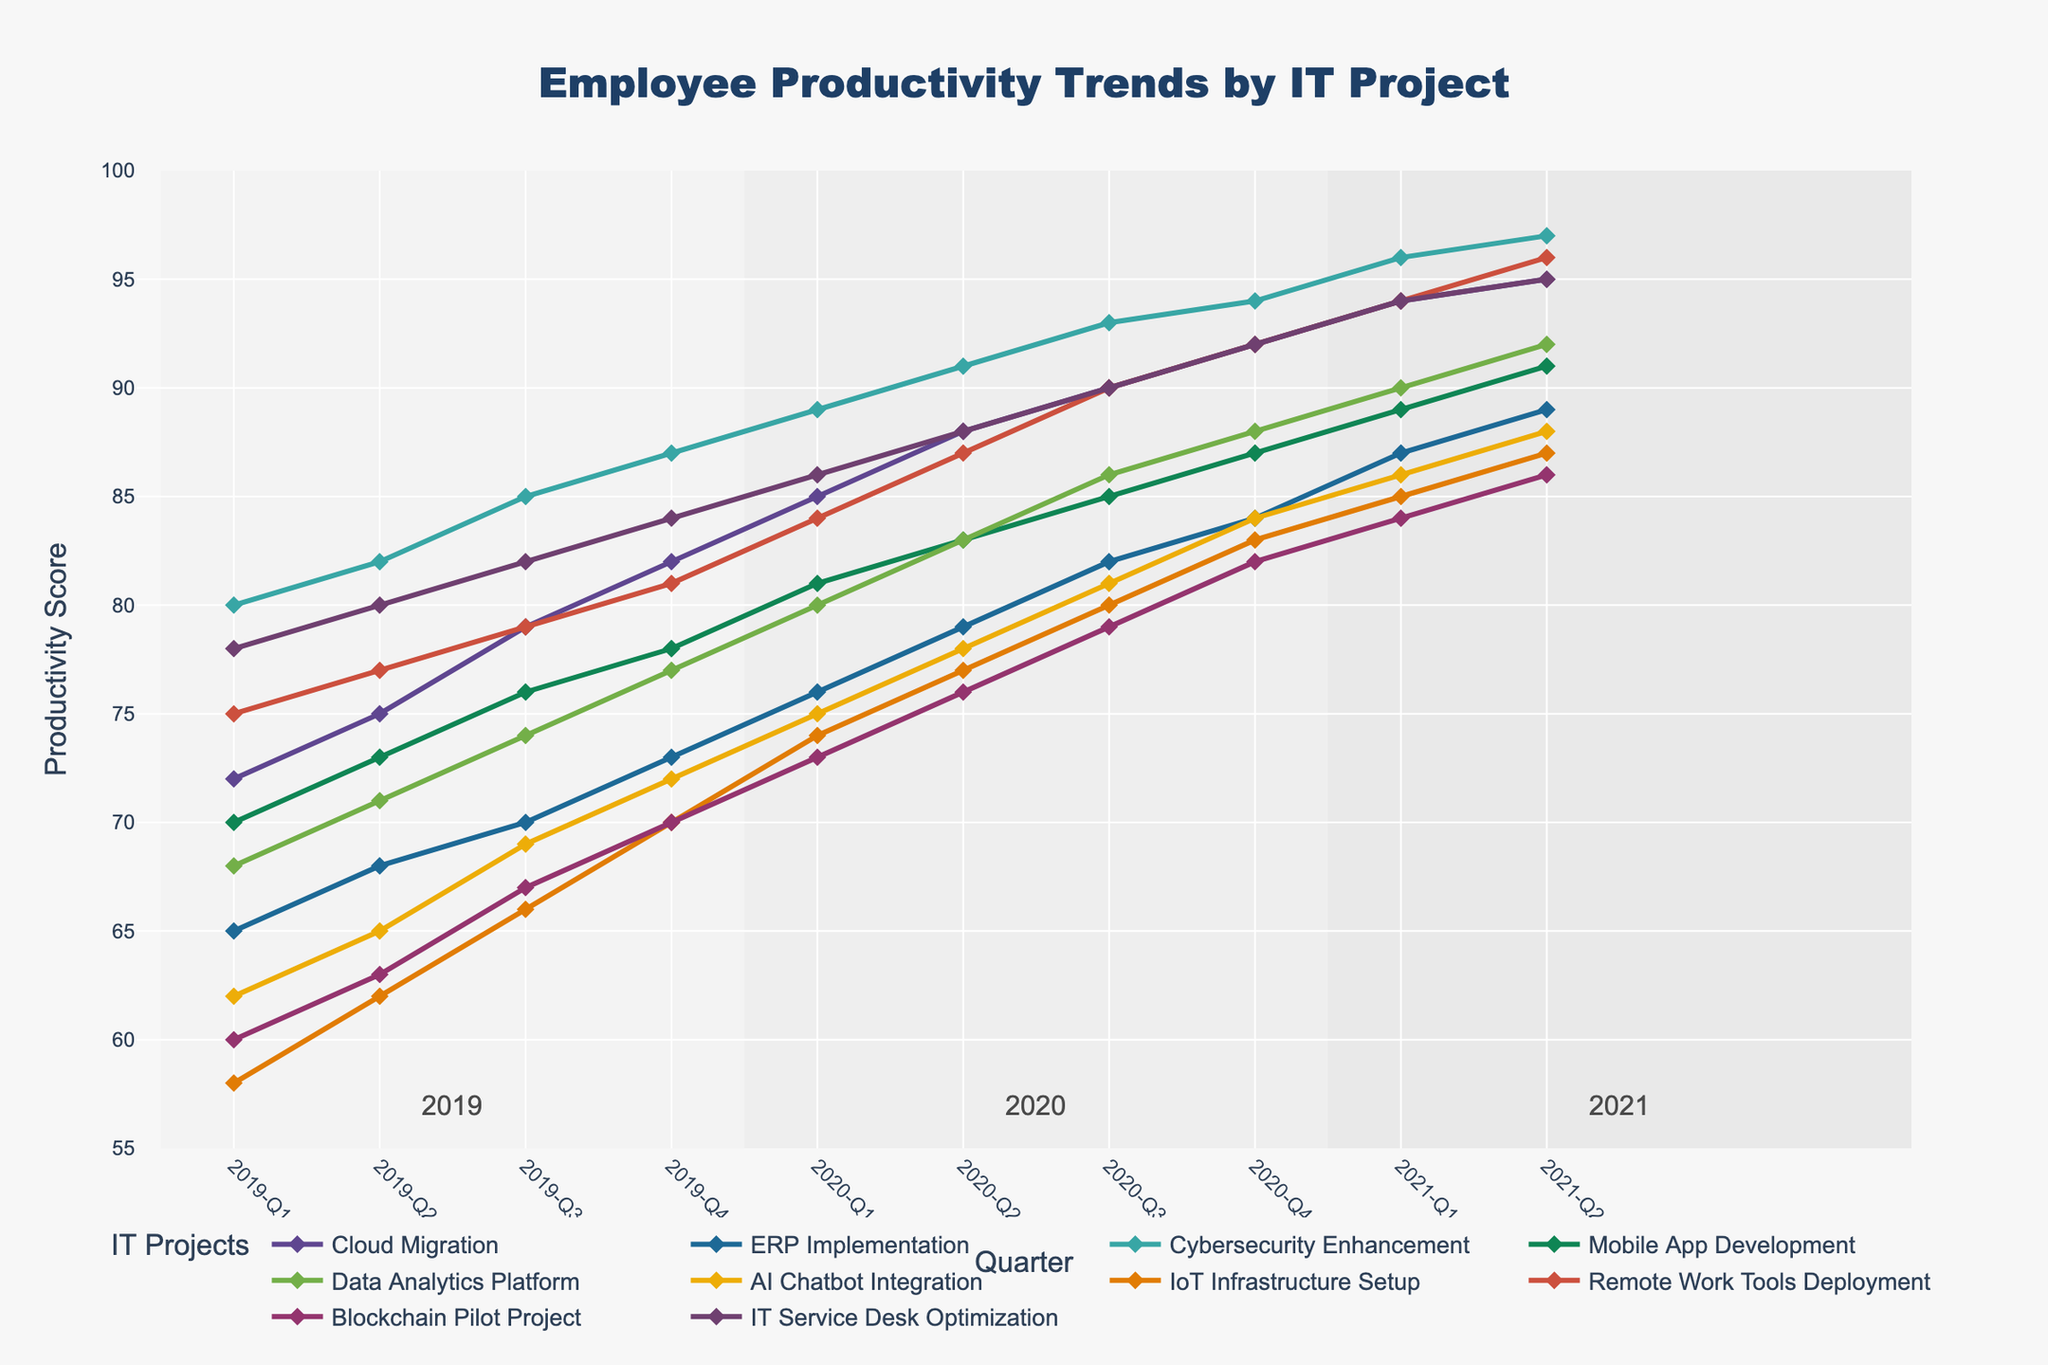What project had the highest productivity at the end of 2021-Q2? To find the project with the highest productivity, check the productivity score for each project in 2021-Q2 and see which one is the highest. From the data: Cloud Migration (95), ERP Implementation (89), Cybersecurity Enhancement (97), Mobile App Development (91), Data Analytics Platform (92), AI Chatbot Integration (88), IoT Infrastructure Setup (87), Remote Work Tools Deployment (96), Blockchain Pilot Project (86), IT Service Desk Optimization (95). Cybersecurity Enhancement has the highest productivity score of 97.
Answer: Cybersecurity Enhancement How did the productivity trend of the 'Mobile App Development' project progress from 2019-Q1 to 2021-Q2? To understand the trend, look at the productivity scores for 'Mobile App Development' across all quarters: 2019-Q1 (70), 2019-Q2 (73), 2019-Q3 (76), 2019-Q4 (78), 2020-Q1 (81), 2020-Q2 (83), 2020-Q3 (85), 2020-Q4 (87), 2021-Q1 (89), 2021-Q2 (91). The trend shows a consistent increase every quarter.
Answer: Increasing trend Which project showed the greatest increase in productivity from 2019-Q1 to 2021-Q2? Calculate the increase in productivity for each project from 2019-Q1 to 2021-Q2 and compare them. For Cloud Migration: 95-72=23, ERP Implementation: 89-65=24, Cybersecurity Enhancement: 97-80=17, Mobile App Development: 91-70=21, Data Analytics Platform: 92-68=24, AI Chatbot Integration: 88-62=26, IoT Infrastructure Setup: 87-58=29, Remote Work Tools Deployment: 96-75=21, Blockchain Pilot Project: 86-60=26, IT Service Desk Optimization: 95-78=17. IoT Infrastructure Setup shows the greatest increase of 29.
Answer: IoT Infrastructure Setup Compare the productivity score of 'AI Chatbot Integration' and 'Blockchain Pilot Project' at 2020-Q2. Which one was higher? Check the productivity scores for these two projects at 2020-Q2. AI Chatbot Integration: 78, Blockchain Pilot Project: 76. AI Chatbot Integration had a higher score.
Answer: AI Chatbot Integration What is the overall productivity trend across all projects? Observe the combined general trend for all projects from 2019-Q1 to 2021-Q2. All projects show an increasing trend in productivity over time though the rate of increase varies.
Answer: Increasing trend Which project had a consistent increase in productivity every quarter? Identify the projects where productivity increased without any drop or plateau in any quarter. Reviewing the data, all available projects had consistent increases: Cloud Migration, ERP Implementation, Cybersecurity Enhancement, Mobile App Development, Data Analytics Platform, AI Chatbot Integration, IoT Infrastructure Setup, Remote Work Tools Deployment, Blockchain Pilot Project, and IT Service Desk Optimization.
Answer: All projects Between 'Data Analytics Platform' and 'IT Service Desk Optimization', which showed a higher productivity score in 2020-Q4? Check the productivity scores of these two projects in 2020-Q4. Data Analytics Platform: 88, IT Service Desk Optimization: 92. IT Service Desk Optimization had a higher score.
Answer: IT Service Desk Optimization In which quarter did 'Remote Work Tools Deployment' and 'Cloud Migration' report the same productivity score? Compare the productivity scores for the two projects across all quarters and find when they match. In 2021-Q1, Remote Work Tools Deployment and Cloud Migration both have a productivity score of 94.
Answer: 2021-Q1 